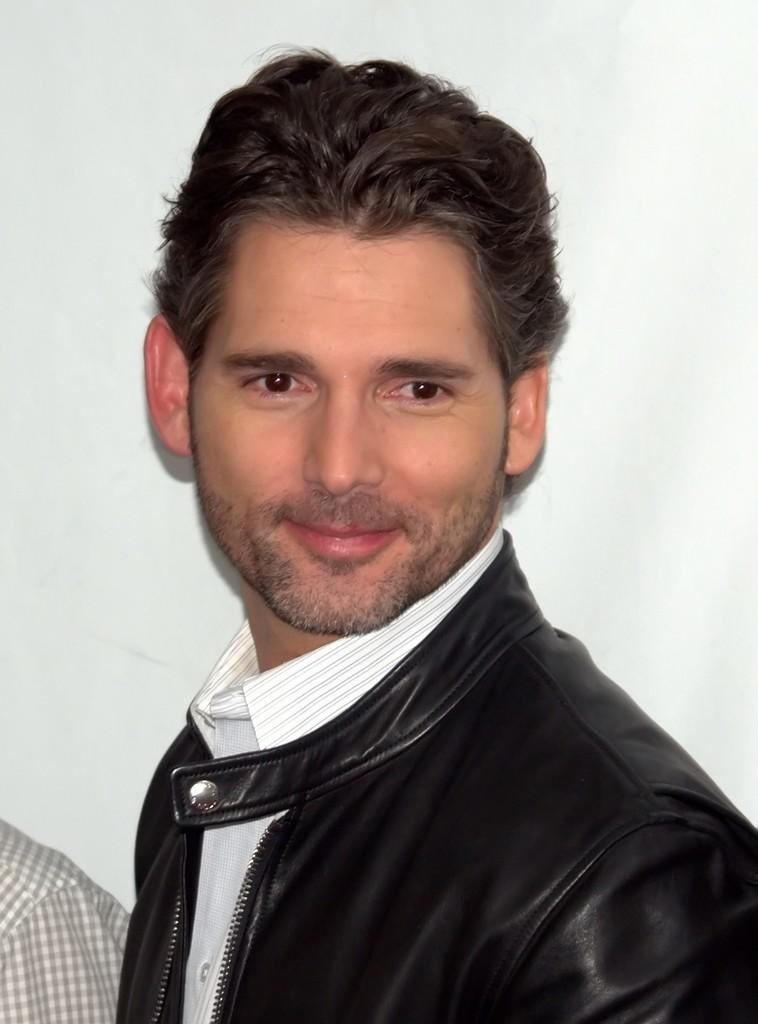What is the main subject in the foreground of the picture? There is a man in the foreground of the picture. What is the man wearing? The man is wearing a black jacket. What expression does the man have on his face? The man has a smile on his face. What can be seen in the background of the image? There is a hand of a person and a wall in the background of the image. How many trees are visible in the image? There are no trees visible in the image. What type of match is being played in the background of the image? There is no match or game being played in the image; only a hand and a wall are visible in the background. 